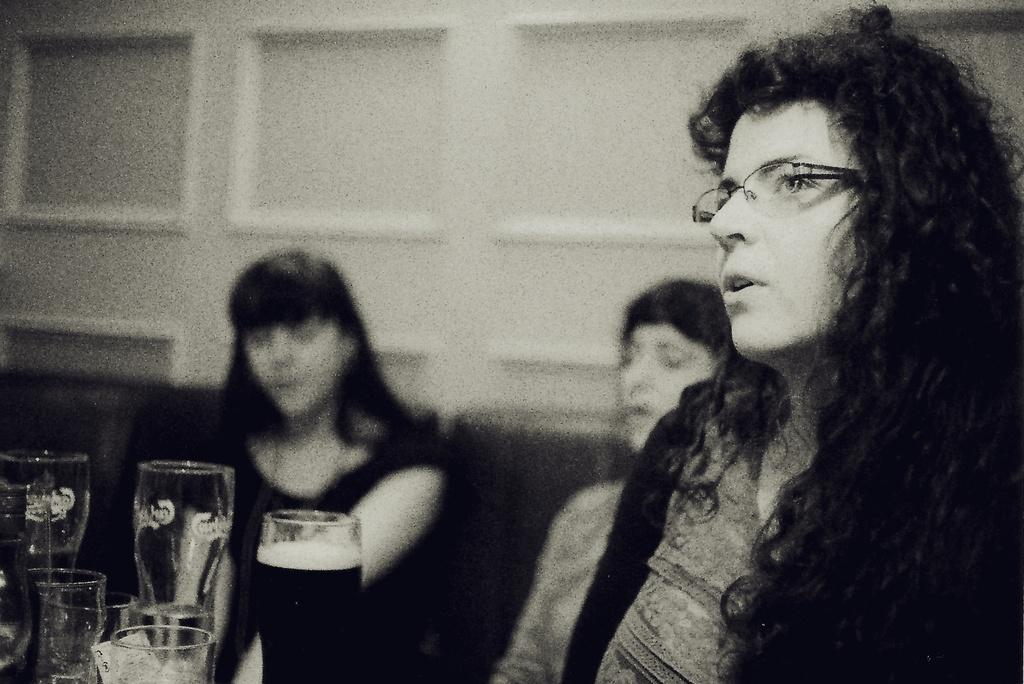What is the color scheme of the image? The image is black and white. Who is present in the image? There is a woman in the image. What is the woman wearing? The woman is wearing spectacles. What can be seen on the left side of the image? There are glasses on the left side of the image. What is visible in the background of the image? There are people and a wall visible in the background of the image. What type of magic is the woman performing in the image? There is no indication of magic or any magical activity in the image. How does the woman say good-bye to the people in the background? The image does not show any interaction between the woman and the people in the background, nor does it depict any form of good-bye. 